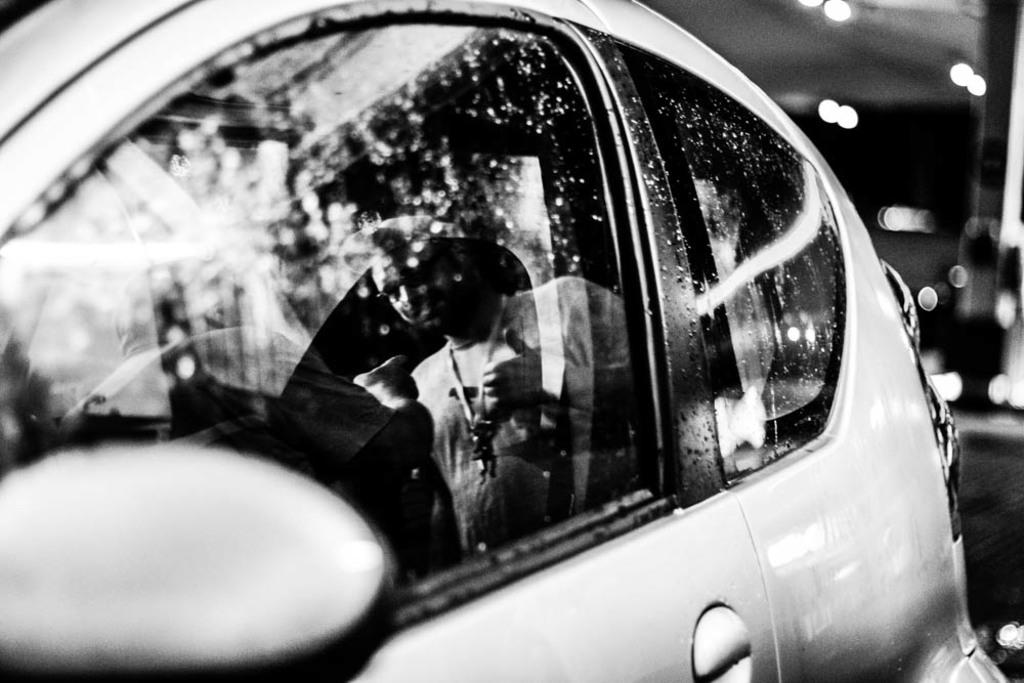What is the color scheme of the image? The image is black and white. What is the main subject of the image? There is a car in the image. Can you describe the person visible in the car's mirror? A person is visible in the car's mirror. What is the background of the image? The background of the image is black. What else can be seen in the background? There are lights visible in the background. What type of egg is being used as a prop in the image? There is no egg present in the image. How does the beam of light affect the car's appearance in the image? There is no beam of light present in the image. 